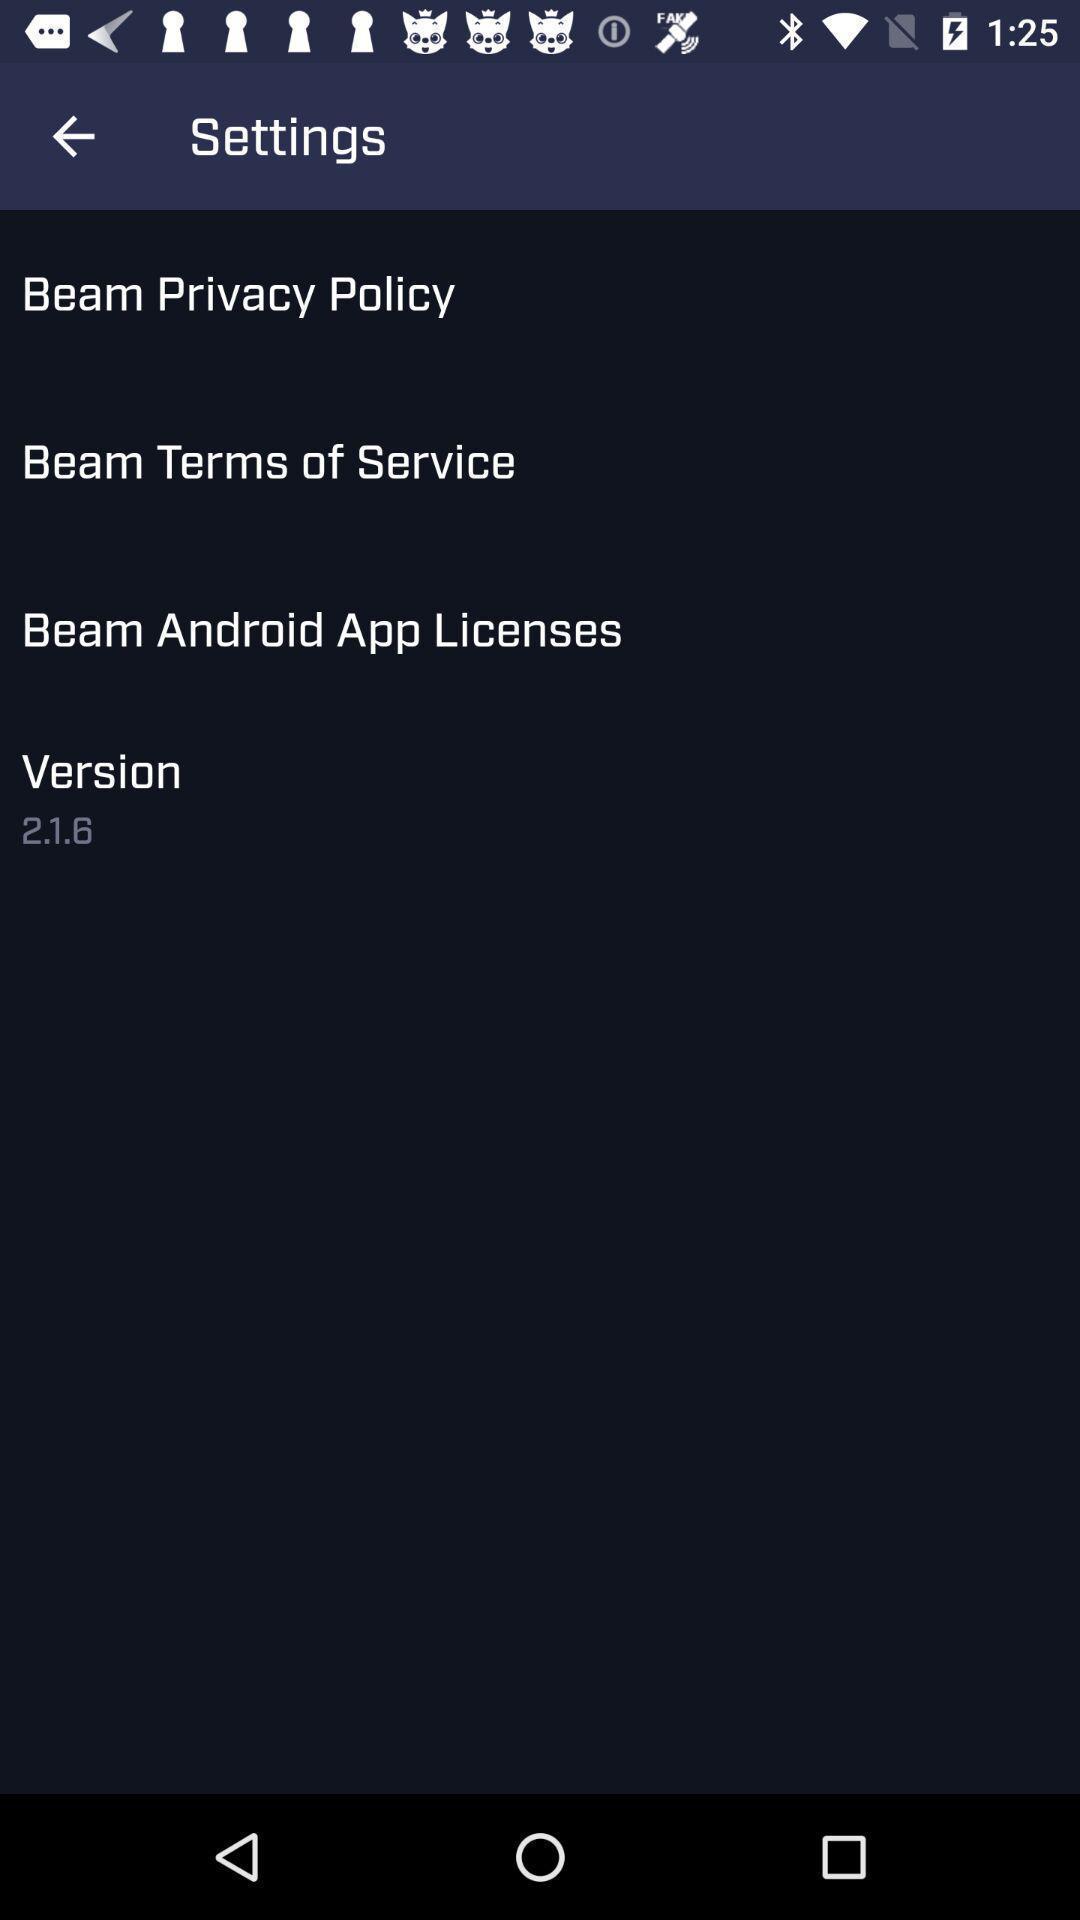Tell me about the visual elements in this screen capture. Settings page with different options. 